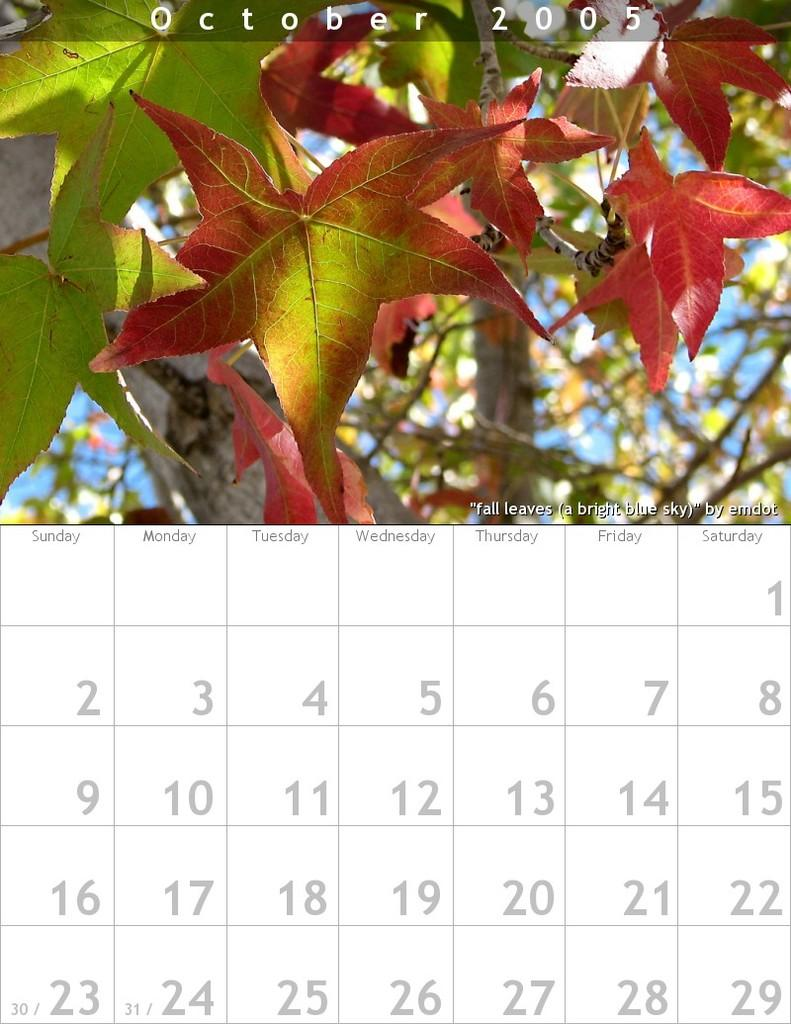What is the main object in the image? There is a calendar in the image. Can you describe the calendar in more detail? Unfortunately, the provided facts do not give any additional details about the calendar. What type of brass instrument is being played in the image? There is no brass instrument or any indication of music being played in the image; it only features a calendar. 